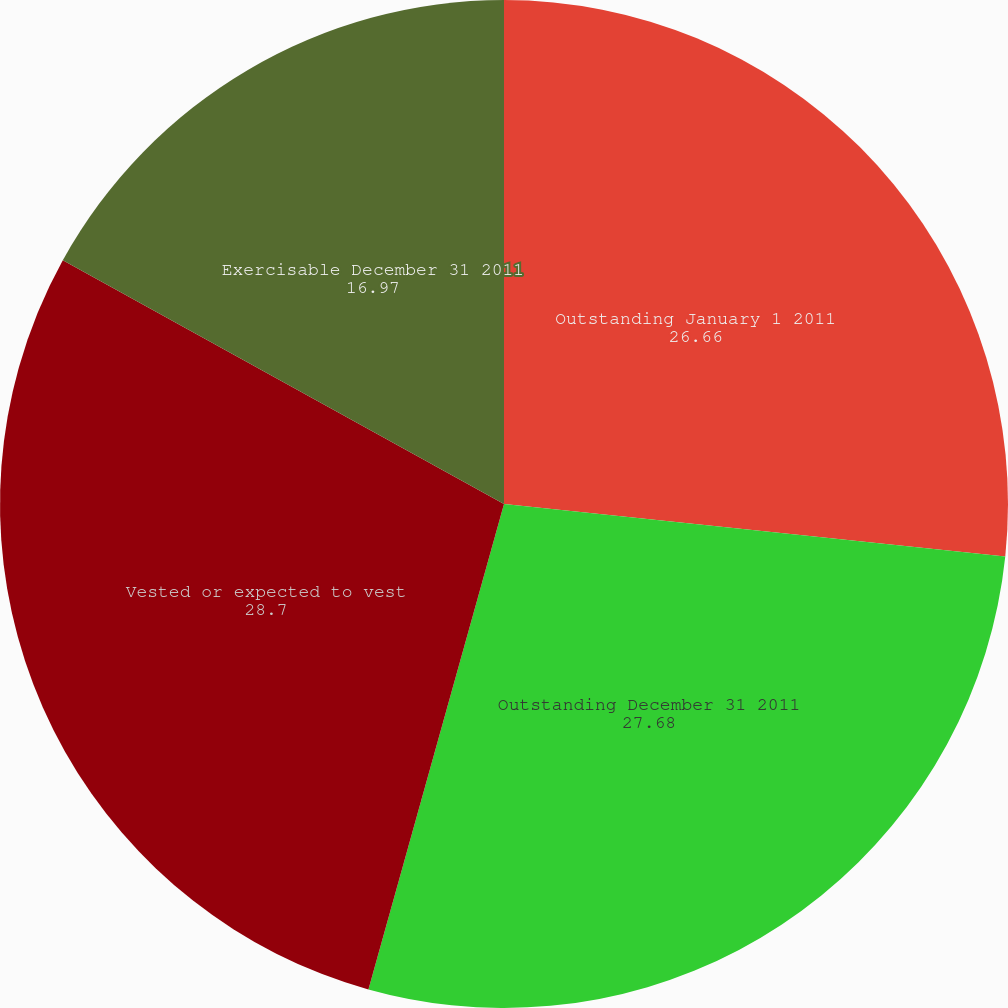Convert chart. <chart><loc_0><loc_0><loc_500><loc_500><pie_chart><fcel>Outstanding January 1 2011<fcel>Outstanding December 31 2011<fcel>Vested or expected to vest<fcel>Exercisable December 31 2011<nl><fcel>26.66%<fcel>27.68%<fcel>28.7%<fcel>16.97%<nl></chart> 